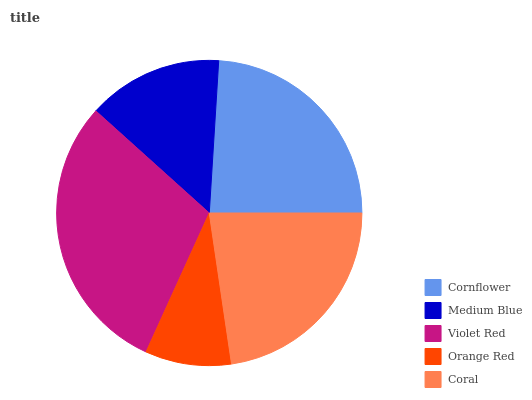Is Orange Red the minimum?
Answer yes or no. Yes. Is Violet Red the maximum?
Answer yes or no. Yes. Is Medium Blue the minimum?
Answer yes or no. No. Is Medium Blue the maximum?
Answer yes or no. No. Is Cornflower greater than Medium Blue?
Answer yes or no. Yes. Is Medium Blue less than Cornflower?
Answer yes or no. Yes. Is Medium Blue greater than Cornflower?
Answer yes or no. No. Is Cornflower less than Medium Blue?
Answer yes or no. No. Is Coral the high median?
Answer yes or no. Yes. Is Coral the low median?
Answer yes or no. Yes. Is Cornflower the high median?
Answer yes or no. No. Is Cornflower the low median?
Answer yes or no. No. 